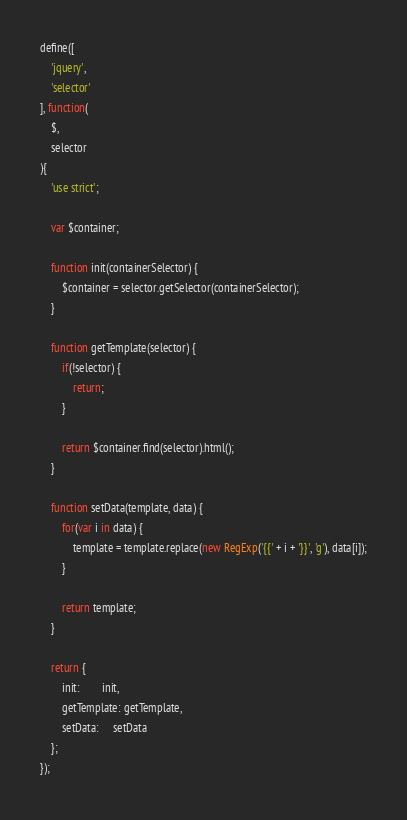<code> <loc_0><loc_0><loc_500><loc_500><_JavaScript_>define([
    'jquery',
    'selector'
], function(
    $,
    selector
){
    'use strict';

    var $container;

    function init(containerSelector) {
        $container = selector.getSelector(containerSelector);
    }

    function getTemplate(selector) {
        if(!selector) {
            return;
        }

        return $container.find(selector).html();
    }

    function setData(template, data) {
        for(var i in data) {
            template = template.replace(new RegExp('{{' + i + '}}', 'g'), data[i]);
        }

        return template;
    }

    return {
        init:        init,
        getTemplate: getTemplate,
        setData:     setData
    };
});
</code> 